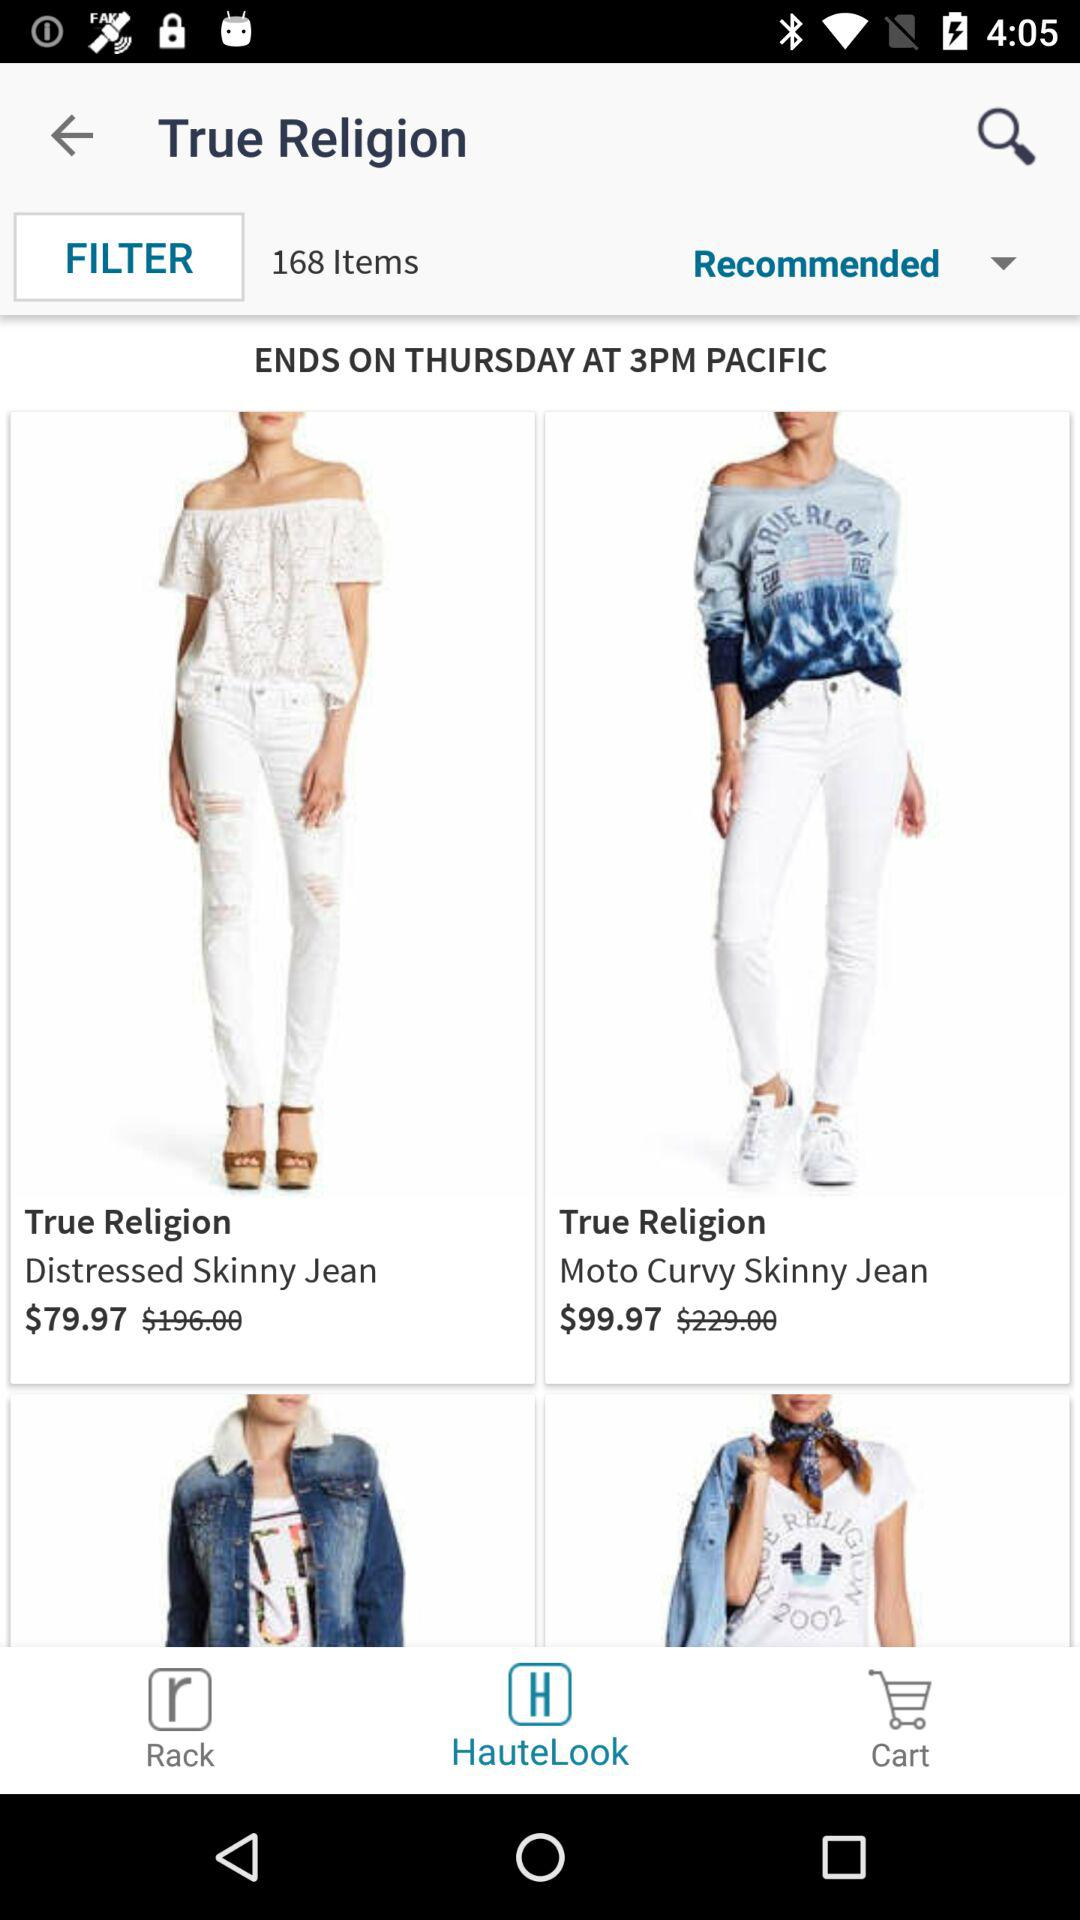What is the recommended number of items? There are 168 recommended items. 